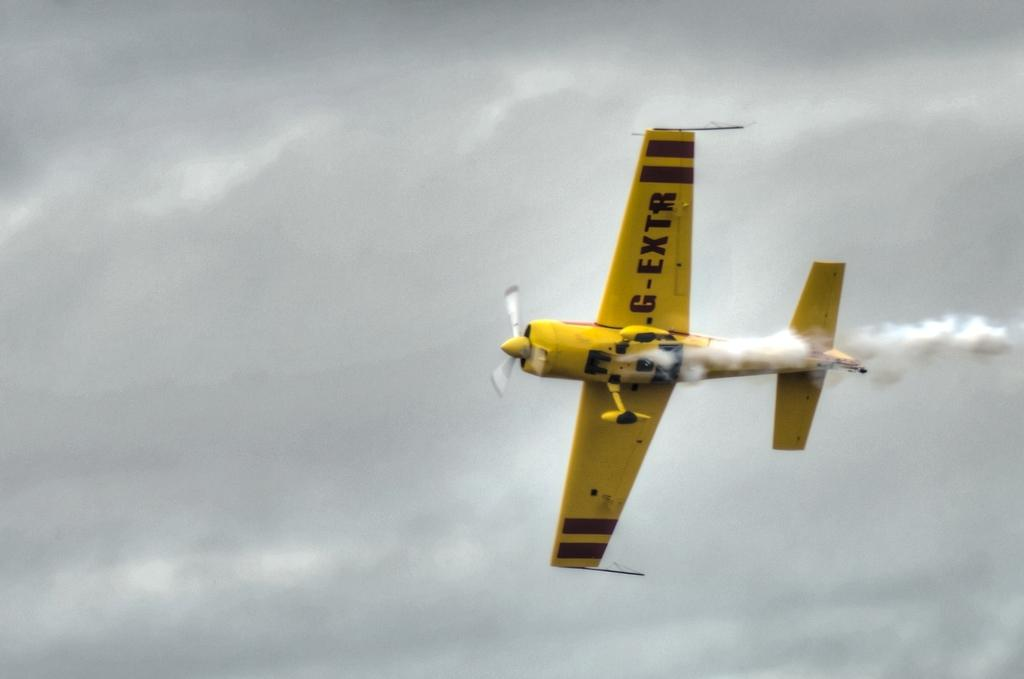<image>
Render a clear and concise summary of the photo. Yellow airplane with the plate of  G-EXTR is flying through the air. 